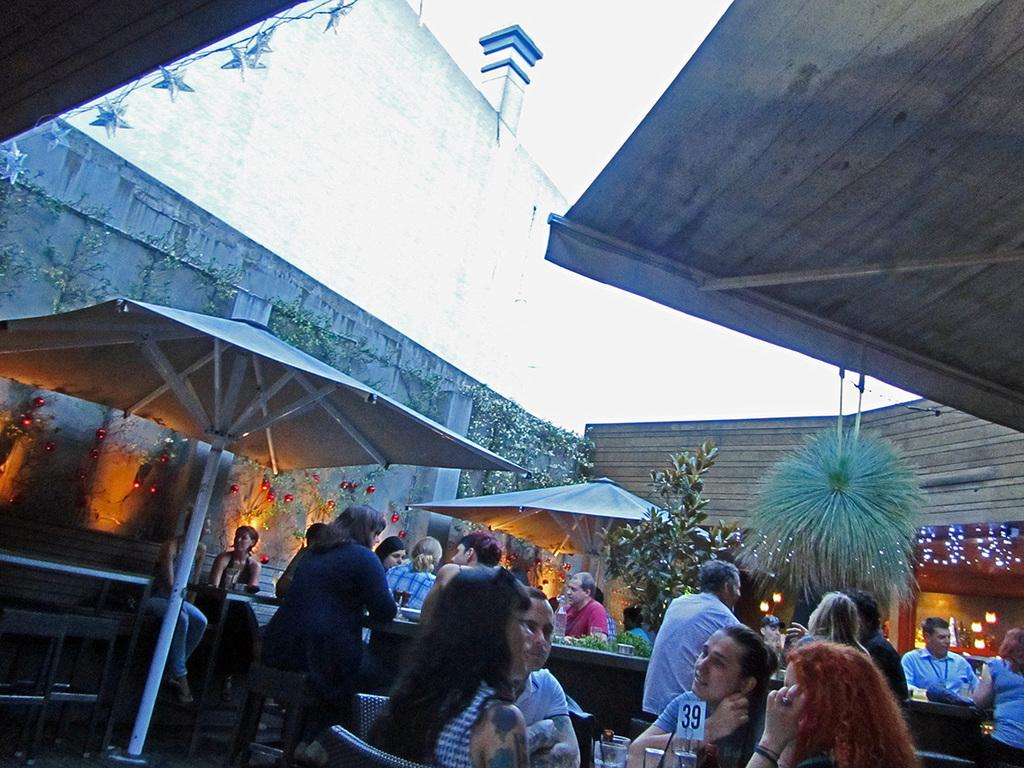What type of establishment is shown in the image? The image depicts a restaurant. What are the people in the image doing? There are people sitting at tables in the restaurant. What can be seen between the tables and the restaurant? There are trees between the tables and the restaurant. How is the restaurant decorated? The restaurant is decorated with lights. Can you tell me what type of snail is crawling on the office partner's desk in the image? There is no snail or office partner present in the image; it depicts a restaurant with people sitting at tables. 